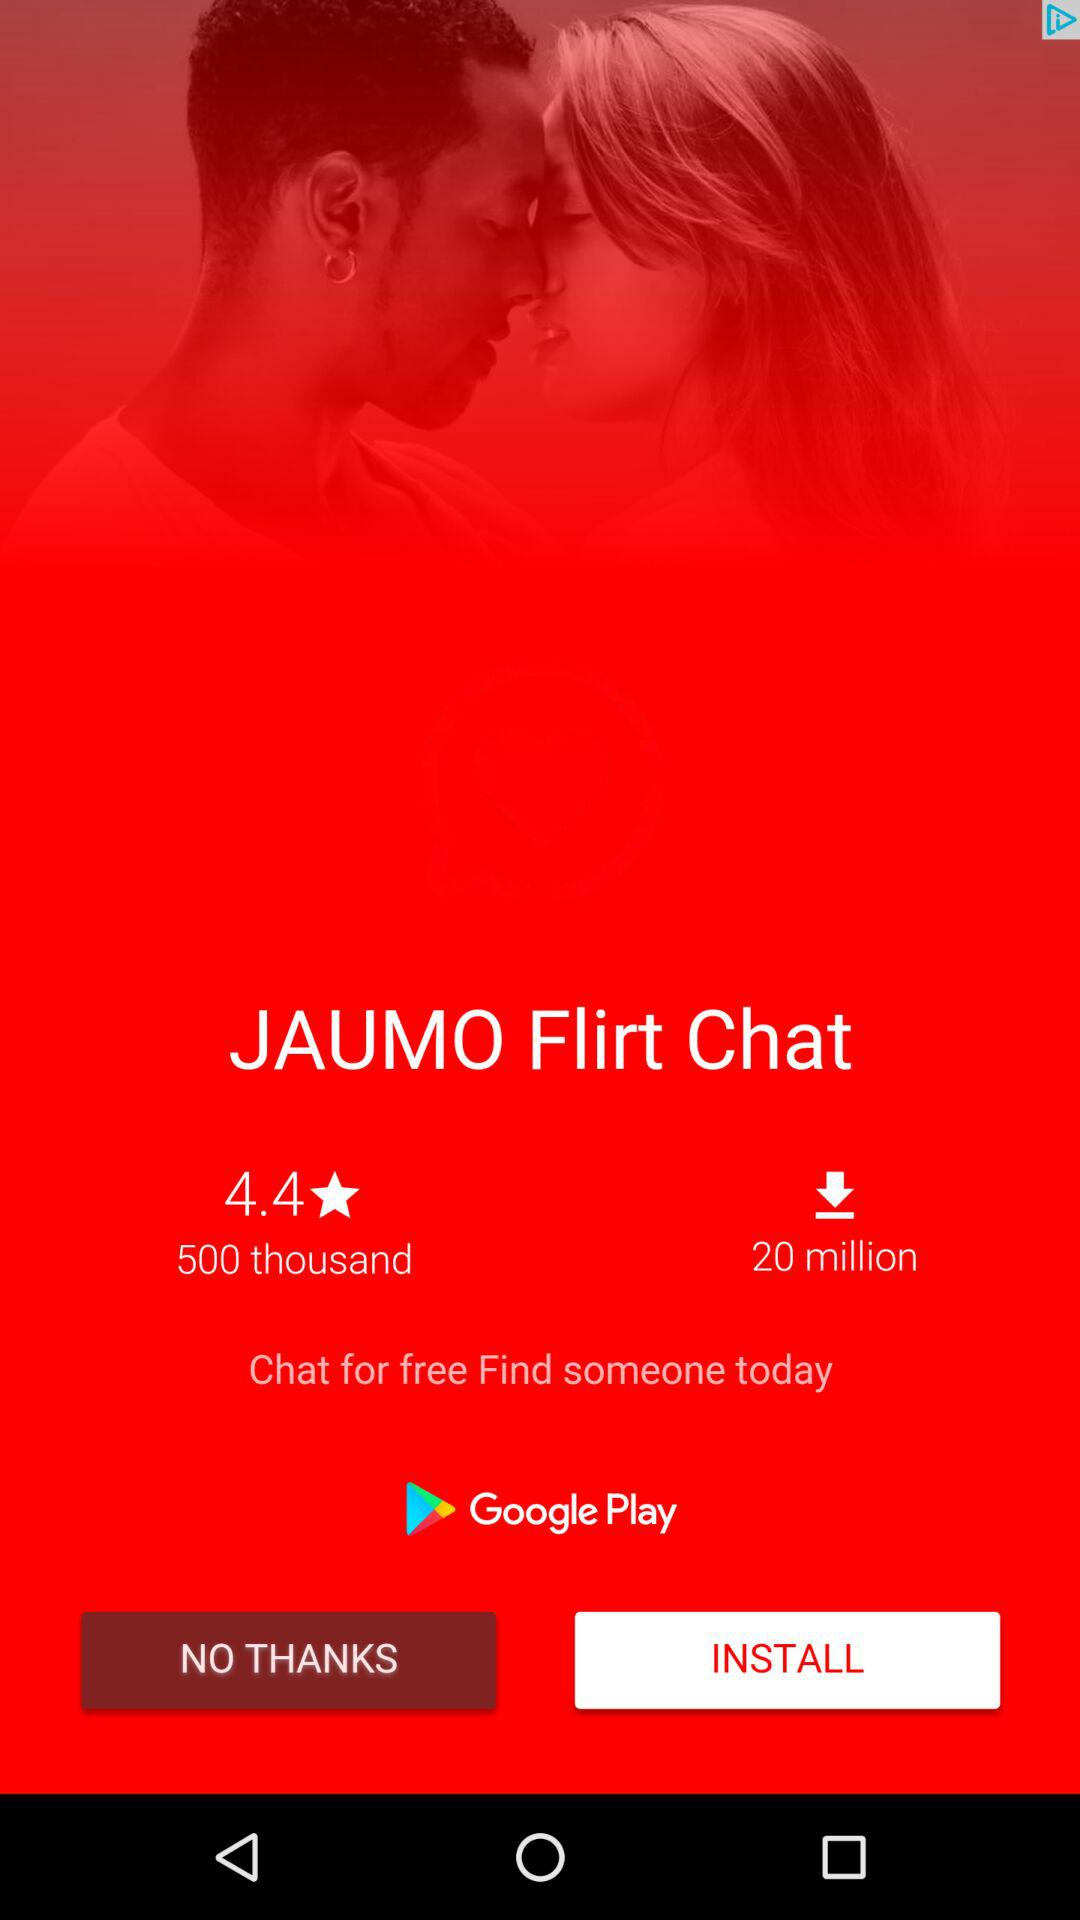How many more downloads does the app have than reviews?
Answer the question using a single word or phrase. 19.5 million 